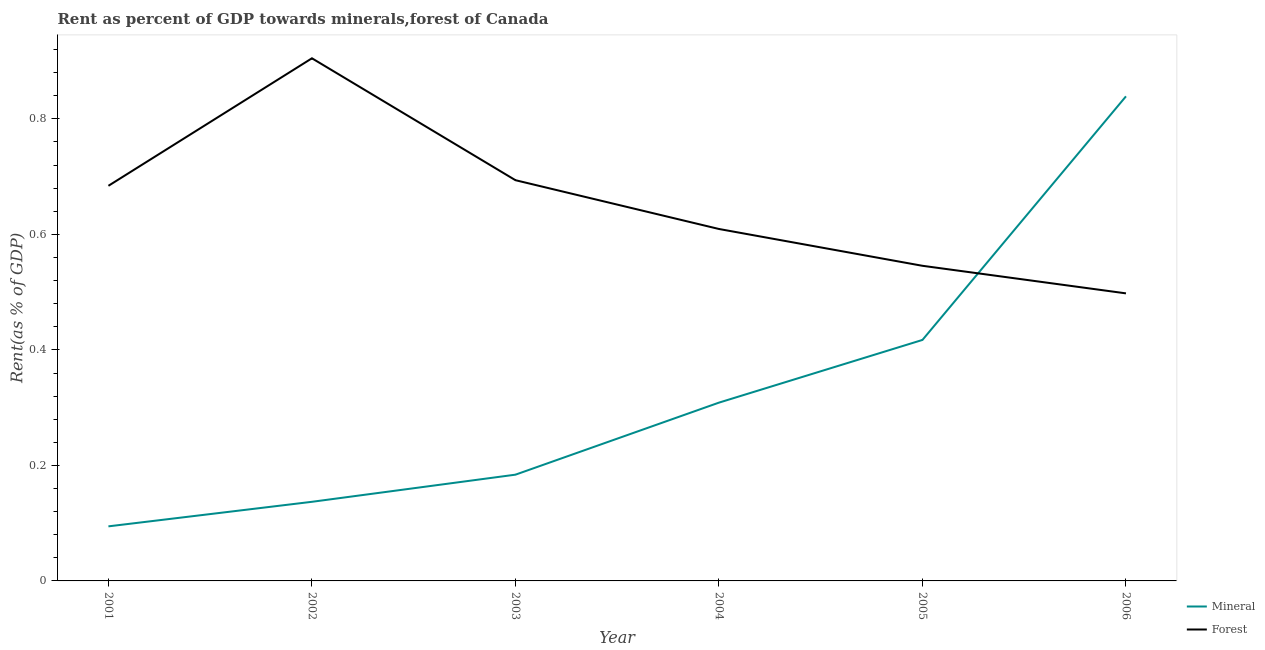What is the forest rent in 2003?
Your response must be concise. 0.69. Across all years, what is the maximum mineral rent?
Your answer should be compact. 0.84. Across all years, what is the minimum forest rent?
Ensure brevity in your answer.  0.5. In which year was the forest rent maximum?
Provide a succinct answer. 2002. What is the total mineral rent in the graph?
Your response must be concise. 1.98. What is the difference between the forest rent in 2001 and that in 2002?
Your answer should be very brief. -0.22. What is the difference between the forest rent in 2004 and the mineral rent in 2005?
Give a very brief answer. 0.19. What is the average mineral rent per year?
Your response must be concise. 0.33. In the year 2004, what is the difference between the forest rent and mineral rent?
Your answer should be very brief. 0.3. In how many years, is the mineral rent greater than 0.6400000000000001 %?
Give a very brief answer. 1. What is the ratio of the mineral rent in 2003 to that in 2006?
Your answer should be compact. 0.22. What is the difference between the highest and the second highest forest rent?
Offer a very short reply. 0.21. What is the difference between the highest and the lowest mineral rent?
Give a very brief answer. 0.74. In how many years, is the mineral rent greater than the average mineral rent taken over all years?
Ensure brevity in your answer.  2. Is the sum of the forest rent in 2004 and 2005 greater than the maximum mineral rent across all years?
Keep it short and to the point. Yes. Is the forest rent strictly greater than the mineral rent over the years?
Offer a very short reply. No. Is the mineral rent strictly less than the forest rent over the years?
Give a very brief answer. No. How many years are there in the graph?
Provide a succinct answer. 6. Does the graph contain any zero values?
Make the answer very short. No. How are the legend labels stacked?
Offer a terse response. Vertical. What is the title of the graph?
Ensure brevity in your answer.  Rent as percent of GDP towards minerals,forest of Canada. Does "Methane emissions" appear as one of the legend labels in the graph?
Give a very brief answer. No. What is the label or title of the X-axis?
Your answer should be very brief. Year. What is the label or title of the Y-axis?
Offer a very short reply. Rent(as % of GDP). What is the Rent(as % of GDP) in Mineral in 2001?
Give a very brief answer. 0.09. What is the Rent(as % of GDP) in Forest in 2001?
Offer a terse response. 0.68. What is the Rent(as % of GDP) in Mineral in 2002?
Your response must be concise. 0.14. What is the Rent(as % of GDP) of Forest in 2002?
Give a very brief answer. 0.9. What is the Rent(as % of GDP) in Mineral in 2003?
Keep it short and to the point. 0.18. What is the Rent(as % of GDP) of Forest in 2003?
Your answer should be very brief. 0.69. What is the Rent(as % of GDP) of Mineral in 2004?
Keep it short and to the point. 0.31. What is the Rent(as % of GDP) in Forest in 2004?
Make the answer very short. 0.61. What is the Rent(as % of GDP) in Mineral in 2005?
Keep it short and to the point. 0.42. What is the Rent(as % of GDP) of Forest in 2005?
Offer a terse response. 0.55. What is the Rent(as % of GDP) in Mineral in 2006?
Give a very brief answer. 0.84. What is the Rent(as % of GDP) of Forest in 2006?
Your answer should be very brief. 0.5. Across all years, what is the maximum Rent(as % of GDP) in Mineral?
Your answer should be compact. 0.84. Across all years, what is the maximum Rent(as % of GDP) in Forest?
Give a very brief answer. 0.9. Across all years, what is the minimum Rent(as % of GDP) in Mineral?
Provide a succinct answer. 0.09. Across all years, what is the minimum Rent(as % of GDP) of Forest?
Provide a succinct answer. 0.5. What is the total Rent(as % of GDP) in Mineral in the graph?
Make the answer very short. 1.98. What is the total Rent(as % of GDP) of Forest in the graph?
Ensure brevity in your answer.  3.94. What is the difference between the Rent(as % of GDP) in Mineral in 2001 and that in 2002?
Offer a very short reply. -0.04. What is the difference between the Rent(as % of GDP) in Forest in 2001 and that in 2002?
Offer a terse response. -0.22. What is the difference between the Rent(as % of GDP) in Mineral in 2001 and that in 2003?
Give a very brief answer. -0.09. What is the difference between the Rent(as % of GDP) in Forest in 2001 and that in 2003?
Keep it short and to the point. -0.01. What is the difference between the Rent(as % of GDP) of Mineral in 2001 and that in 2004?
Ensure brevity in your answer.  -0.21. What is the difference between the Rent(as % of GDP) in Forest in 2001 and that in 2004?
Ensure brevity in your answer.  0.07. What is the difference between the Rent(as % of GDP) of Mineral in 2001 and that in 2005?
Offer a terse response. -0.32. What is the difference between the Rent(as % of GDP) of Forest in 2001 and that in 2005?
Make the answer very short. 0.14. What is the difference between the Rent(as % of GDP) of Mineral in 2001 and that in 2006?
Ensure brevity in your answer.  -0.74. What is the difference between the Rent(as % of GDP) of Forest in 2001 and that in 2006?
Your answer should be compact. 0.19. What is the difference between the Rent(as % of GDP) of Mineral in 2002 and that in 2003?
Provide a succinct answer. -0.05. What is the difference between the Rent(as % of GDP) in Forest in 2002 and that in 2003?
Your answer should be very brief. 0.21. What is the difference between the Rent(as % of GDP) in Mineral in 2002 and that in 2004?
Your answer should be compact. -0.17. What is the difference between the Rent(as % of GDP) in Forest in 2002 and that in 2004?
Your response must be concise. 0.3. What is the difference between the Rent(as % of GDP) in Mineral in 2002 and that in 2005?
Offer a terse response. -0.28. What is the difference between the Rent(as % of GDP) in Forest in 2002 and that in 2005?
Keep it short and to the point. 0.36. What is the difference between the Rent(as % of GDP) in Mineral in 2002 and that in 2006?
Give a very brief answer. -0.7. What is the difference between the Rent(as % of GDP) of Forest in 2002 and that in 2006?
Your answer should be very brief. 0.41. What is the difference between the Rent(as % of GDP) of Mineral in 2003 and that in 2004?
Keep it short and to the point. -0.12. What is the difference between the Rent(as % of GDP) of Forest in 2003 and that in 2004?
Give a very brief answer. 0.08. What is the difference between the Rent(as % of GDP) in Mineral in 2003 and that in 2005?
Your answer should be compact. -0.23. What is the difference between the Rent(as % of GDP) of Forest in 2003 and that in 2005?
Keep it short and to the point. 0.15. What is the difference between the Rent(as % of GDP) of Mineral in 2003 and that in 2006?
Make the answer very short. -0.66. What is the difference between the Rent(as % of GDP) in Forest in 2003 and that in 2006?
Your answer should be compact. 0.2. What is the difference between the Rent(as % of GDP) of Mineral in 2004 and that in 2005?
Make the answer very short. -0.11. What is the difference between the Rent(as % of GDP) in Forest in 2004 and that in 2005?
Keep it short and to the point. 0.06. What is the difference between the Rent(as % of GDP) of Mineral in 2004 and that in 2006?
Offer a terse response. -0.53. What is the difference between the Rent(as % of GDP) of Forest in 2004 and that in 2006?
Provide a succinct answer. 0.11. What is the difference between the Rent(as % of GDP) of Mineral in 2005 and that in 2006?
Offer a very short reply. -0.42. What is the difference between the Rent(as % of GDP) in Forest in 2005 and that in 2006?
Offer a very short reply. 0.05. What is the difference between the Rent(as % of GDP) of Mineral in 2001 and the Rent(as % of GDP) of Forest in 2002?
Your response must be concise. -0.81. What is the difference between the Rent(as % of GDP) of Mineral in 2001 and the Rent(as % of GDP) of Forest in 2003?
Provide a short and direct response. -0.6. What is the difference between the Rent(as % of GDP) in Mineral in 2001 and the Rent(as % of GDP) in Forest in 2004?
Your response must be concise. -0.51. What is the difference between the Rent(as % of GDP) of Mineral in 2001 and the Rent(as % of GDP) of Forest in 2005?
Ensure brevity in your answer.  -0.45. What is the difference between the Rent(as % of GDP) of Mineral in 2001 and the Rent(as % of GDP) of Forest in 2006?
Your answer should be very brief. -0.4. What is the difference between the Rent(as % of GDP) of Mineral in 2002 and the Rent(as % of GDP) of Forest in 2003?
Your answer should be compact. -0.56. What is the difference between the Rent(as % of GDP) of Mineral in 2002 and the Rent(as % of GDP) of Forest in 2004?
Provide a succinct answer. -0.47. What is the difference between the Rent(as % of GDP) of Mineral in 2002 and the Rent(as % of GDP) of Forest in 2005?
Provide a short and direct response. -0.41. What is the difference between the Rent(as % of GDP) in Mineral in 2002 and the Rent(as % of GDP) in Forest in 2006?
Provide a succinct answer. -0.36. What is the difference between the Rent(as % of GDP) of Mineral in 2003 and the Rent(as % of GDP) of Forest in 2004?
Your answer should be compact. -0.43. What is the difference between the Rent(as % of GDP) of Mineral in 2003 and the Rent(as % of GDP) of Forest in 2005?
Provide a short and direct response. -0.36. What is the difference between the Rent(as % of GDP) of Mineral in 2003 and the Rent(as % of GDP) of Forest in 2006?
Offer a very short reply. -0.31. What is the difference between the Rent(as % of GDP) in Mineral in 2004 and the Rent(as % of GDP) in Forest in 2005?
Provide a succinct answer. -0.24. What is the difference between the Rent(as % of GDP) of Mineral in 2004 and the Rent(as % of GDP) of Forest in 2006?
Keep it short and to the point. -0.19. What is the difference between the Rent(as % of GDP) of Mineral in 2005 and the Rent(as % of GDP) of Forest in 2006?
Your response must be concise. -0.08. What is the average Rent(as % of GDP) in Mineral per year?
Offer a very short reply. 0.33. What is the average Rent(as % of GDP) in Forest per year?
Your answer should be compact. 0.66. In the year 2001, what is the difference between the Rent(as % of GDP) in Mineral and Rent(as % of GDP) in Forest?
Keep it short and to the point. -0.59. In the year 2002, what is the difference between the Rent(as % of GDP) in Mineral and Rent(as % of GDP) in Forest?
Your answer should be very brief. -0.77. In the year 2003, what is the difference between the Rent(as % of GDP) of Mineral and Rent(as % of GDP) of Forest?
Offer a very short reply. -0.51. In the year 2004, what is the difference between the Rent(as % of GDP) of Mineral and Rent(as % of GDP) of Forest?
Your answer should be very brief. -0.3. In the year 2005, what is the difference between the Rent(as % of GDP) in Mineral and Rent(as % of GDP) in Forest?
Keep it short and to the point. -0.13. In the year 2006, what is the difference between the Rent(as % of GDP) of Mineral and Rent(as % of GDP) of Forest?
Provide a succinct answer. 0.34. What is the ratio of the Rent(as % of GDP) of Mineral in 2001 to that in 2002?
Offer a terse response. 0.69. What is the ratio of the Rent(as % of GDP) in Forest in 2001 to that in 2002?
Provide a succinct answer. 0.76. What is the ratio of the Rent(as % of GDP) in Mineral in 2001 to that in 2003?
Your answer should be compact. 0.51. What is the ratio of the Rent(as % of GDP) of Mineral in 2001 to that in 2004?
Keep it short and to the point. 0.31. What is the ratio of the Rent(as % of GDP) in Forest in 2001 to that in 2004?
Your answer should be compact. 1.12. What is the ratio of the Rent(as % of GDP) in Mineral in 2001 to that in 2005?
Offer a terse response. 0.23. What is the ratio of the Rent(as % of GDP) of Forest in 2001 to that in 2005?
Offer a very short reply. 1.25. What is the ratio of the Rent(as % of GDP) of Mineral in 2001 to that in 2006?
Keep it short and to the point. 0.11. What is the ratio of the Rent(as % of GDP) in Forest in 2001 to that in 2006?
Keep it short and to the point. 1.37. What is the ratio of the Rent(as % of GDP) in Mineral in 2002 to that in 2003?
Offer a terse response. 0.74. What is the ratio of the Rent(as % of GDP) of Forest in 2002 to that in 2003?
Keep it short and to the point. 1.3. What is the ratio of the Rent(as % of GDP) in Mineral in 2002 to that in 2004?
Your response must be concise. 0.44. What is the ratio of the Rent(as % of GDP) of Forest in 2002 to that in 2004?
Offer a terse response. 1.49. What is the ratio of the Rent(as % of GDP) in Mineral in 2002 to that in 2005?
Make the answer very short. 0.33. What is the ratio of the Rent(as % of GDP) in Forest in 2002 to that in 2005?
Provide a short and direct response. 1.66. What is the ratio of the Rent(as % of GDP) of Mineral in 2002 to that in 2006?
Provide a short and direct response. 0.16. What is the ratio of the Rent(as % of GDP) of Forest in 2002 to that in 2006?
Make the answer very short. 1.82. What is the ratio of the Rent(as % of GDP) in Mineral in 2003 to that in 2004?
Ensure brevity in your answer.  0.6. What is the ratio of the Rent(as % of GDP) in Forest in 2003 to that in 2004?
Provide a short and direct response. 1.14. What is the ratio of the Rent(as % of GDP) of Mineral in 2003 to that in 2005?
Make the answer very short. 0.44. What is the ratio of the Rent(as % of GDP) of Forest in 2003 to that in 2005?
Keep it short and to the point. 1.27. What is the ratio of the Rent(as % of GDP) in Mineral in 2003 to that in 2006?
Your response must be concise. 0.22. What is the ratio of the Rent(as % of GDP) in Forest in 2003 to that in 2006?
Make the answer very short. 1.39. What is the ratio of the Rent(as % of GDP) of Mineral in 2004 to that in 2005?
Keep it short and to the point. 0.74. What is the ratio of the Rent(as % of GDP) of Forest in 2004 to that in 2005?
Ensure brevity in your answer.  1.12. What is the ratio of the Rent(as % of GDP) of Mineral in 2004 to that in 2006?
Provide a short and direct response. 0.37. What is the ratio of the Rent(as % of GDP) of Forest in 2004 to that in 2006?
Make the answer very short. 1.22. What is the ratio of the Rent(as % of GDP) of Mineral in 2005 to that in 2006?
Offer a very short reply. 0.5. What is the ratio of the Rent(as % of GDP) in Forest in 2005 to that in 2006?
Offer a very short reply. 1.1. What is the difference between the highest and the second highest Rent(as % of GDP) in Mineral?
Make the answer very short. 0.42. What is the difference between the highest and the second highest Rent(as % of GDP) of Forest?
Offer a very short reply. 0.21. What is the difference between the highest and the lowest Rent(as % of GDP) in Mineral?
Give a very brief answer. 0.74. What is the difference between the highest and the lowest Rent(as % of GDP) in Forest?
Make the answer very short. 0.41. 